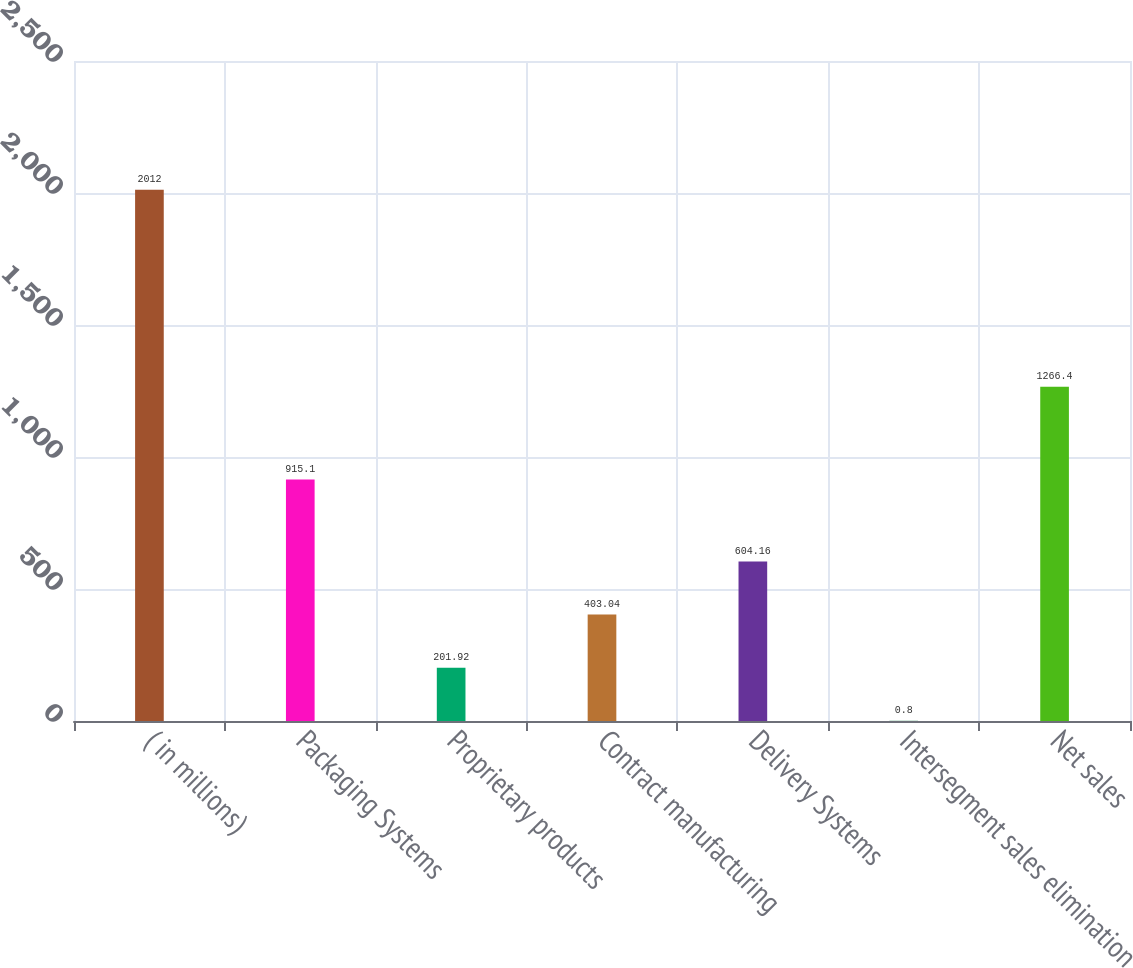<chart> <loc_0><loc_0><loc_500><loc_500><bar_chart><fcel>( in millions)<fcel>Packaging Systems<fcel>Proprietary products<fcel>Contract manufacturing<fcel>Delivery Systems<fcel>Intersegment sales elimination<fcel>Net sales<nl><fcel>2012<fcel>915.1<fcel>201.92<fcel>403.04<fcel>604.16<fcel>0.8<fcel>1266.4<nl></chart> 